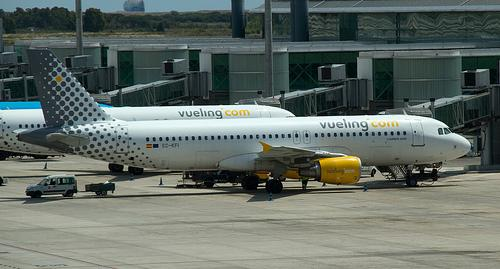Illustrate the primary subject of the image and mention a few noticeable details. The main subject is a white airplane with a distinctive circle pattern tail, surrounded by vehicles such as a white van and various airport buildings. Describe the main object in the image and touch on other noticeable components. A white airplane with a unique tail design is the central point of the image, complemented by an array of airport-related vehicles and structures nearby. Provide an explanation of the most important object in the photo and mention a few adjacent elements. The primary focus is a white plane, which stands out with its intriguing tail design, accompanied by ground vehicles and airport buildings in the background. Write a concise overview of the image emphasizing the distinctive objects. At an active airport tarmac, this photo highlights a white plane with a circular pattern on its tail, accompanied by several ground vehicles and structures. Provide a brief description of the central object in the image and its surroundings. A white plane stands on a gray-colored airport tarmac, surrounded by many smaller airport elements such as vehicles, buildings, and ground markings. What does the image seem to be about and what elements stand out? The image focuses on aviation activities at an airport, featuring a white plane with an interesting tail design, alongside other planes and ground vehicles. Describe the overall scenery of the image focusing on the atmosphere. The image showcases a busy airport tarmac on a clear, blue, cloudless day with various planes, vehicles, and equipment scattered around. Briefly describe the key visual elements and the setting present in the image. The image showcases a populous airport tarmac scene including a white plane with a distinct tail design, various ground vehicles, and buildings in the background. Mention the primary focus of the image and describe a couple of additional details that catch the eye. The image centers on a white plane with a notable circular tail pattern, surrounded by smaller details such as a white van, ground markings, and buildings. Pick three prominent objects in the image and explain their appearance. A large white plane features a unique circle pattern on its tail, a white van nearby is connected to a trailer, and green and white buildings loom in the background. 